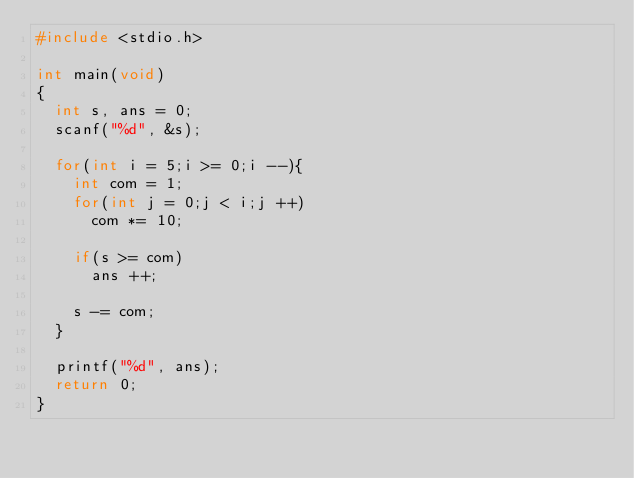Convert code to text. <code><loc_0><loc_0><loc_500><loc_500><_C_>#include <stdio.h>

int main(void)
{
	int s, ans = 0;	
	scanf("%d", &s);
	
	for(int i = 5;i >= 0;i --){
		int com = 1;
		for(int j = 0;j < i;j ++)
			com *= 10;
		
		if(s >= com)
			ans ++;
		
		s -= com;
	}
	
	printf("%d", ans);
	return 0;
}</code> 